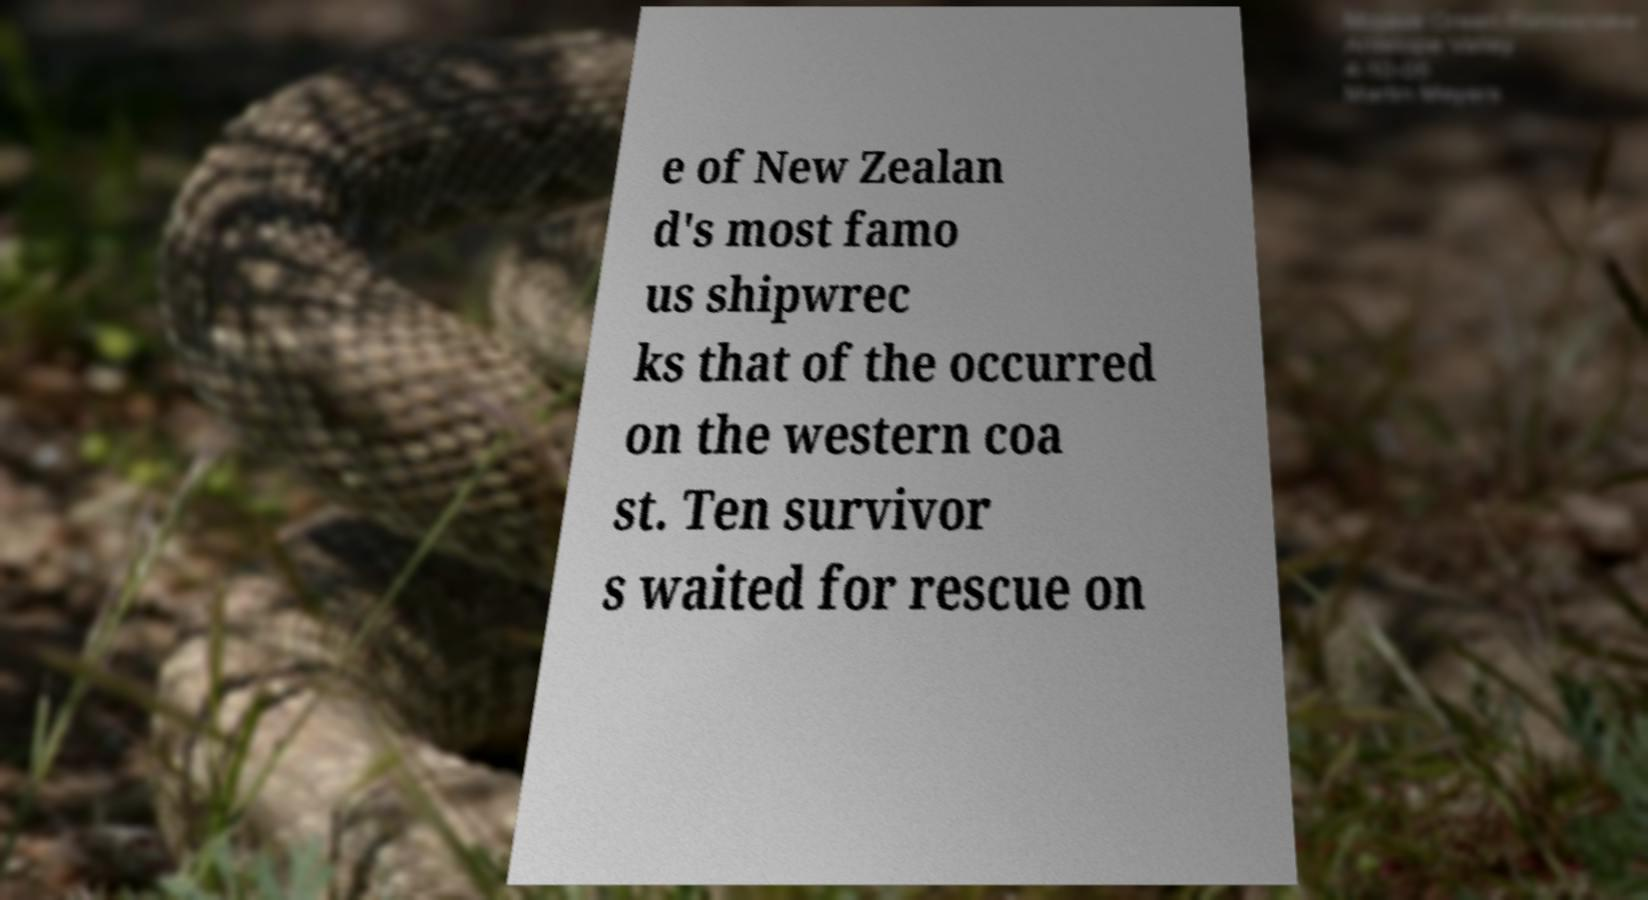There's text embedded in this image that I need extracted. Can you transcribe it verbatim? e of New Zealan d's most famo us shipwrec ks that of the occurred on the western coa st. Ten survivor s waited for rescue on 